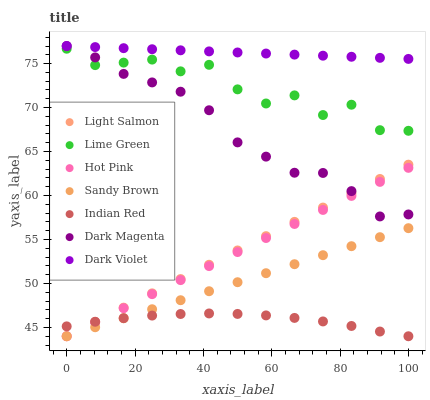Does Indian Red have the minimum area under the curve?
Answer yes or no. Yes. Does Dark Violet have the maximum area under the curve?
Answer yes or no. Yes. Does Dark Magenta have the minimum area under the curve?
Answer yes or no. No. Does Dark Magenta have the maximum area under the curve?
Answer yes or no. No. Is Light Salmon the smoothest?
Answer yes or no. Yes. Is Lime Green the roughest?
Answer yes or no. Yes. Is Dark Magenta the smoothest?
Answer yes or no. No. Is Dark Magenta the roughest?
Answer yes or no. No. Does Light Salmon have the lowest value?
Answer yes or no. Yes. Does Dark Magenta have the lowest value?
Answer yes or no. No. Does Dark Violet have the highest value?
Answer yes or no. Yes. Does Lime Green have the highest value?
Answer yes or no. No. Is Light Salmon less than Dark Violet?
Answer yes or no. Yes. Is Dark Violet greater than Sandy Brown?
Answer yes or no. Yes. Does Indian Red intersect Light Salmon?
Answer yes or no. Yes. Is Indian Red less than Light Salmon?
Answer yes or no. No. Is Indian Red greater than Light Salmon?
Answer yes or no. No. Does Light Salmon intersect Dark Violet?
Answer yes or no. No. 